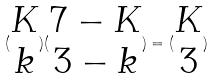<formula> <loc_0><loc_0><loc_500><loc_500>( \begin{matrix} K \\ k \end{matrix} ) ( \begin{matrix} 7 - K \\ 3 - k \end{matrix} ) = ( \begin{matrix} K \\ 3 \end{matrix} )</formula> 